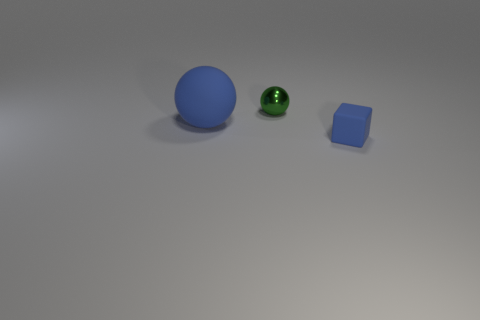Are there any other things that have the same size as the blue matte ball?
Your response must be concise. No. Is there anything else that has the same material as the tiny ball?
Make the answer very short. No. What shape is the other rubber object that is the same color as the big thing?
Offer a terse response. Cube. Is there any other thing that has the same shape as the small blue thing?
Provide a short and direct response. No. Are there more large blue things left of the large rubber sphere than small shiny objects in front of the small blue object?
Offer a very short reply. No. What number of blue balls are left of the blue object in front of the large blue matte ball?
Offer a terse response. 1. How many objects are either spheres or tiny objects?
Your answer should be compact. 3. Does the big blue matte object have the same shape as the metallic object?
Give a very brief answer. Yes. What is the material of the tiny ball?
Provide a succinct answer. Metal. What number of objects are both to the right of the big blue thing and left of the small block?
Your response must be concise. 1. 